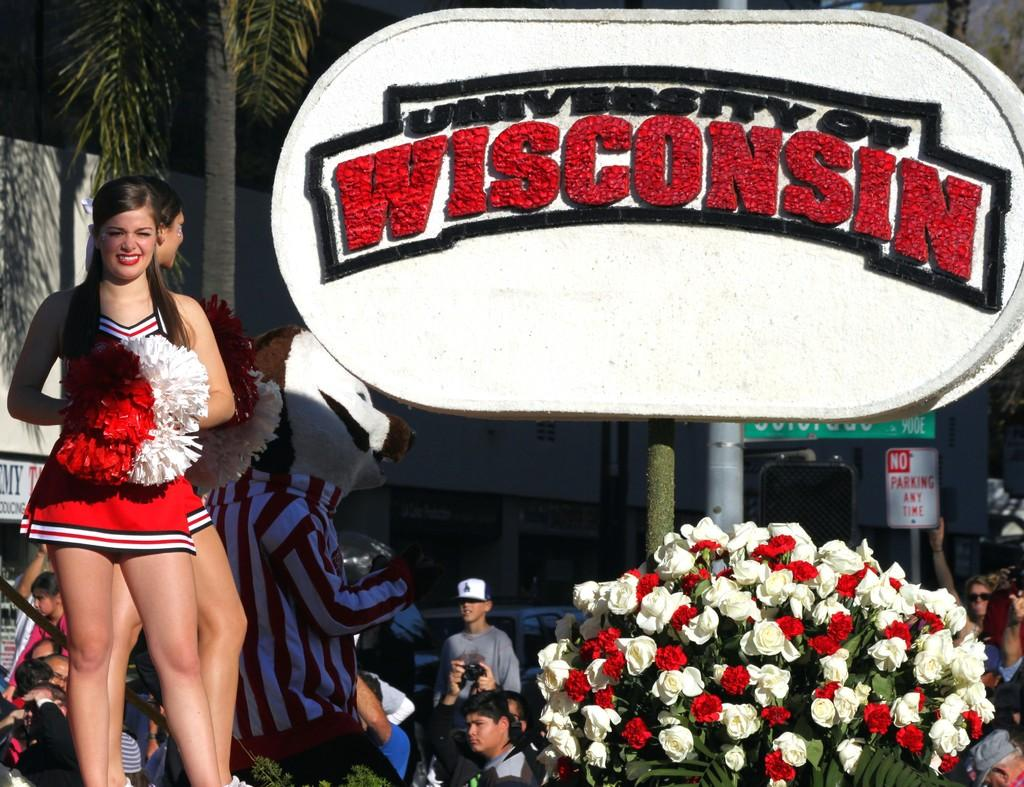<image>
Create a compact narrative representing the image presented. A cheerleader stand on the stage representing University of Wisconsin. 